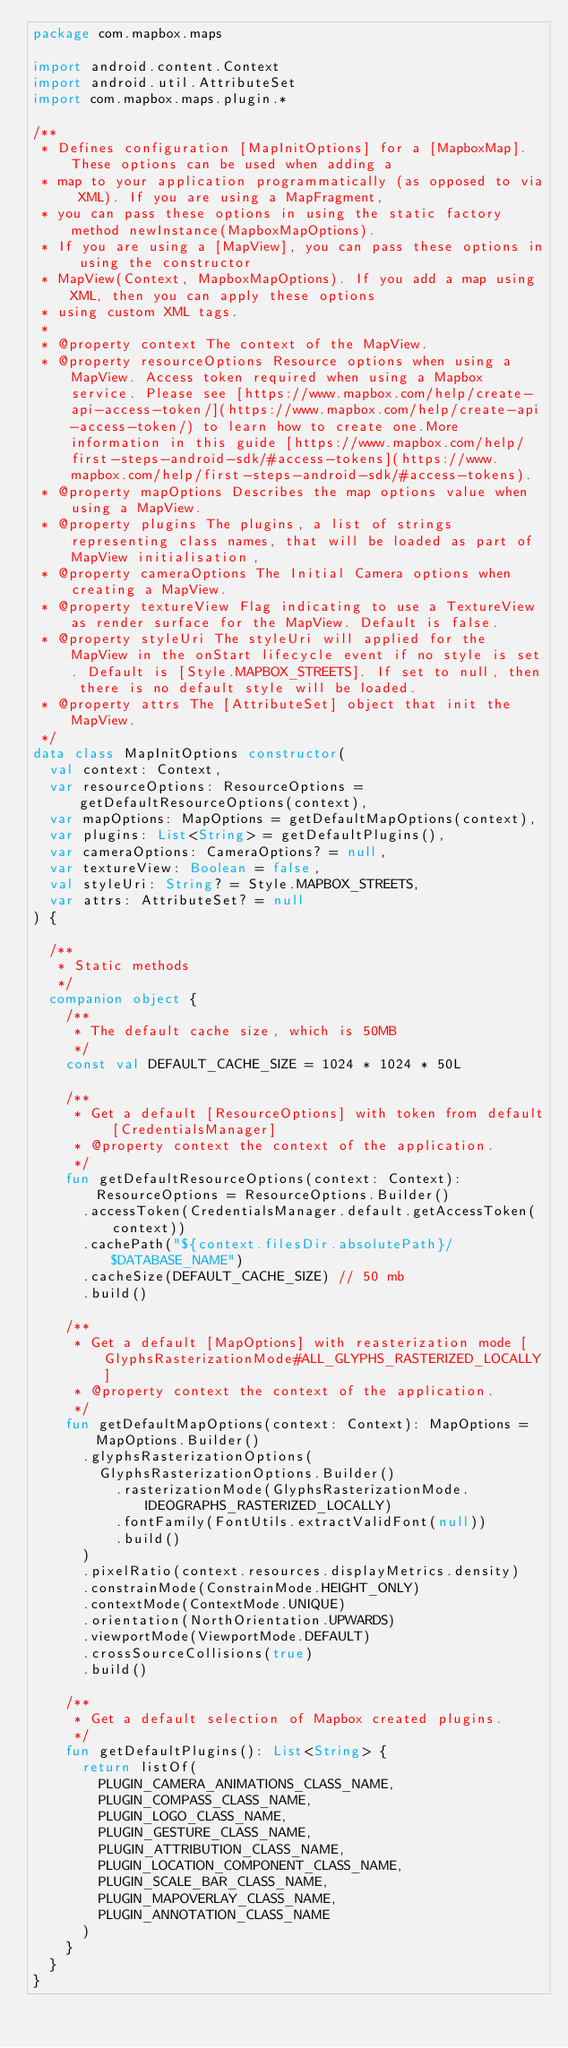<code> <loc_0><loc_0><loc_500><loc_500><_Kotlin_>package com.mapbox.maps

import android.content.Context
import android.util.AttributeSet
import com.mapbox.maps.plugin.*

/**
 * Defines configuration [MapInitOptions] for a [MapboxMap]. These options can be used when adding a
 * map to your application programmatically (as opposed to via XML). If you are using a MapFragment,
 * you can pass these options in using the static factory method newInstance(MapboxMapOptions).
 * If you are using a [MapView], you can pass these options in using the constructor
 * MapView(Context, MapboxMapOptions). If you add a map using XML, then you can apply these options
 * using custom XML tags.
 *
 * @property context The context of the MapView.
 * @property resourceOptions Resource options when using a MapView. Access token required when using a Mapbox service. Please see [https://www.mapbox.com/help/create-api-access-token/](https://www.mapbox.com/help/create-api-access-token/) to learn how to create one.More information in this guide [https://www.mapbox.com/help/first-steps-android-sdk/#access-tokens](https://www.mapbox.com/help/first-steps-android-sdk/#access-tokens).
 * @property mapOptions Describes the map options value when using a MapView.
 * @property plugins The plugins, a list of strings representing class names, that will be loaded as part of MapView initialisation,
 * @property cameraOptions The Initial Camera options when creating a MapView.
 * @property textureView Flag indicating to use a TextureView as render surface for the MapView. Default is false.
 * @property styleUri The styleUri will applied for the MapView in the onStart lifecycle event if no style is set. Default is [Style.MAPBOX_STREETS]. If set to null, then there is no default style will be loaded.
 * @property attrs The [AttributeSet] object that init the MapView.
 */
data class MapInitOptions constructor(
  val context: Context,
  var resourceOptions: ResourceOptions = getDefaultResourceOptions(context),
  var mapOptions: MapOptions = getDefaultMapOptions(context),
  var plugins: List<String> = getDefaultPlugins(),
  var cameraOptions: CameraOptions? = null,
  var textureView: Boolean = false,
  val styleUri: String? = Style.MAPBOX_STREETS,
  var attrs: AttributeSet? = null
) {

  /**
   * Static methods
   */
  companion object {
    /**
     * The default cache size, which is 50MB
     */
    const val DEFAULT_CACHE_SIZE = 1024 * 1024 * 50L

    /**
     * Get a default [ResourceOptions] with token from default [CredentialsManager]
     * @property context the context of the application.
     */
    fun getDefaultResourceOptions(context: Context): ResourceOptions = ResourceOptions.Builder()
      .accessToken(CredentialsManager.default.getAccessToken(context))
      .cachePath("${context.filesDir.absolutePath}/$DATABASE_NAME")
      .cacheSize(DEFAULT_CACHE_SIZE) // 50 mb
      .build()

    /**
     * Get a default [MapOptions] with reasterization mode [GlyphsRasterizationMode#ALL_GLYPHS_RASTERIZED_LOCALLY]
     * @property context the context of the application.
     */
    fun getDefaultMapOptions(context: Context): MapOptions = MapOptions.Builder()
      .glyphsRasterizationOptions(
        GlyphsRasterizationOptions.Builder()
          .rasterizationMode(GlyphsRasterizationMode.IDEOGRAPHS_RASTERIZED_LOCALLY)
          .fontFamily(FontUtils.extractValidFont(null))
          .build()
      )
      .pixelRatio(context.resources.displayMetrics.density)
      .constrainMode(ConstrainMode.HEIGHT_ONLY)
      .contextMode(ContextMode.UNIQUE)
      .orientation(NorthOrientation.UPWARDS)
      .viewportMode(ViewportMode.DEFAULT)
      .crossSourceCollisions(true)
      .build()

    /**
     * Get a default selection of Mapbox created plugins.
     */
    fun getDefaultPlugins(): List<String> {
      return listOf(
        PLUGIN_CAMERA_ANIMATIONS_CLASS_NAME,
        PLUGIN_COMPASS_CLASS_NAME,
        PLUGIN_LOGO_CLASS_NAME,
        PLUGIN_GESTURE_CLASS_NAME,
        PLUGIN_ATTRIBUTION_CLASS_NAME,
        PLUGIN_LOCATION_COMPONENT_CLASS_NAME,
        PLUGIN_SCALE_BAR_CLASS_NAME,
        PLUGIN_MAPOVERLAY_CLASS_NAME,
        PLUGIN_ANNOTATION_CLASS_NAME
      )
    }
  }
}</code> 